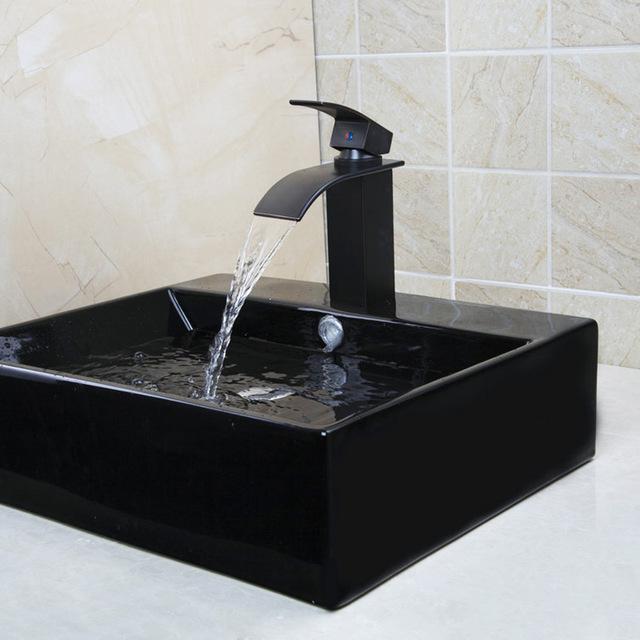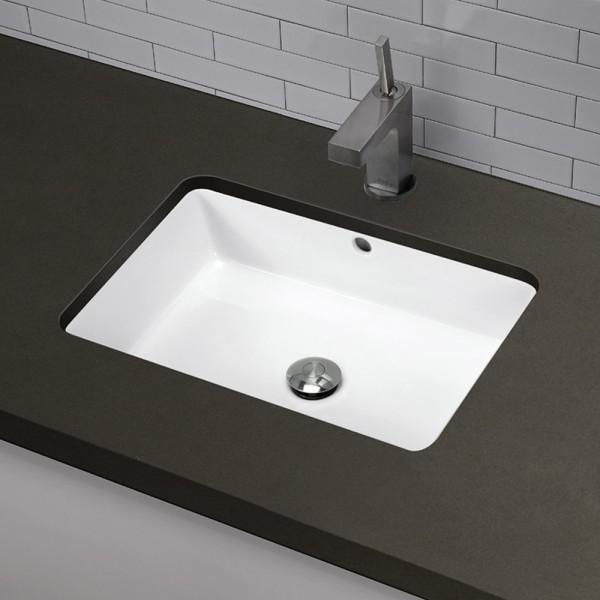The first image is the image on the left, the second image is the image on the right. Examine the images to the left and right. Is the description "The right image shows an oblong bowl-shaped sink." accurate? Answer yes or no. No. 